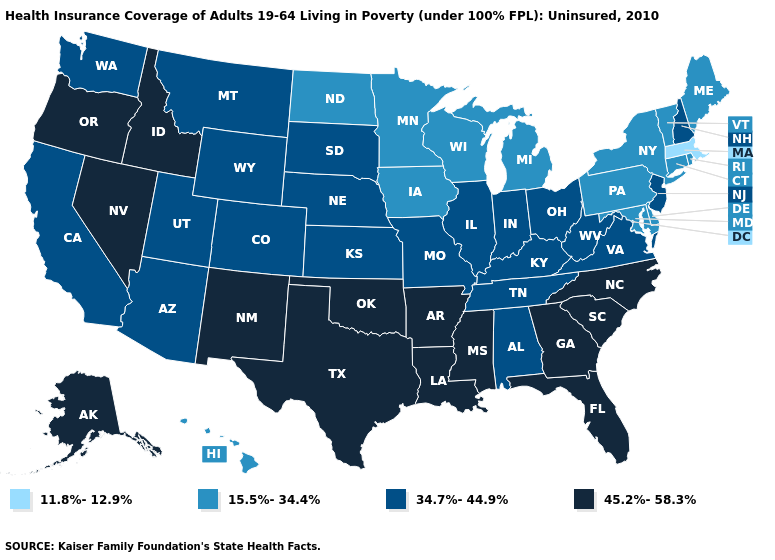Among the states that border North Carolina , does Virginia have the highest value?
Short answer required. No. Name the states that have a value in the range 45.2%-58.3%?
Be succinct. Alaska, Arkansas, Florida, Georgia, Idaho, Louisiana, Mississippi, Nevada, New Mexico, North Carolina, Oklahoma, Oregon, South Carolina, Texas. How many symbols are there in the legend?
Answer briefly. 4. How many symbols are there in the legend?
Concise answer only. 4. What is the lowest value in the Northeast?
Be succinct. 11.8%-12.9%. What is the value of Kentucky?
Keep it brief. 34.7%-44.9%. What is the value of Oregon?
Keep it brief. 45.2%-58.3%. What is the highest value in the USA?
Concise answer only. 45.2%-58.3%. Name the states that have a value in the range 11.8%-12.9%?
Concise answer only. Massachusetts. Does the first symbol in the legend represent the smallest category?
Concise answer only. Yes. Name the states that have a value in the range 11.8%-12.9%?
Short answer required. Massachusetts. Name the states that have a value in the range 45.2%-58.3%?
Answer briefly. Alaska, Arkansas, Florida, Georgia, Idaho, Louisiana, Mississippi, Nevada, New Mexico, North Carolina, Oklahoma, Oregon, South Carolina, Texas. What is the value of Missouri?
Quick response, please. 34.7%-44.9%. Name the states that have a value in the range 45.2%-58.3%?
Concise answer only. Alaska, Arkansas, Florida, Georgia, Idaho, Louisiana, Mississippi, Nevada, New Mexico, North Carolina, Oklahoma, Oregon, South Carolina, Texas. Name the states that have a value in the range 34.7%-44.9%?
Answer briefly. Alabama, Arizona, California, Colorado, Illinois, Indiana, Kansas, Kentucky, Missouri, Montana, Nebraska, New Hampshire, New Jersey, Ohio, South Dakota, Tennessee, Utah, Virginia, Washington, West Virginia, Wyoming. 